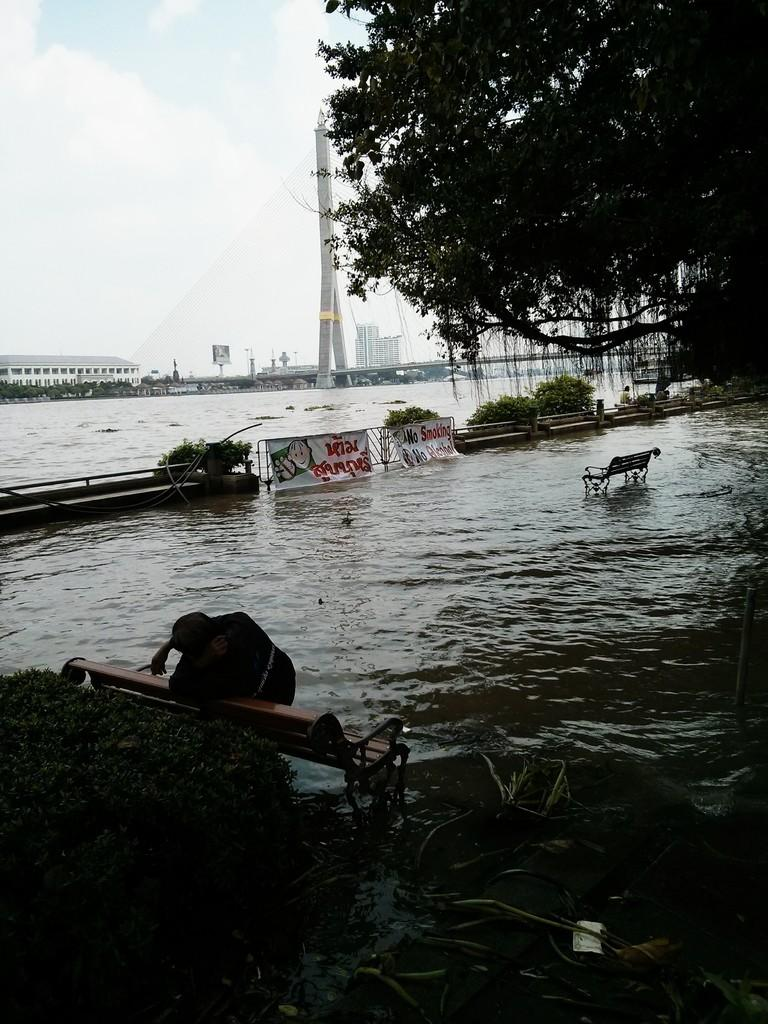What type of seating can be seen in the image? There are benches in the image. What decorative elements are present in the image? There are banners in the image. What type of barrier is visible in the image? There is a fence in the image. What natural element is visible in the image? There is water visible in the image. What type of vegetation is present in the image? There are trees in the image. What type of man-made structures are visible in the image? There are buildings in the image. What is visible in the background of the image? The sky with clouds is visible in the background of the image. Can you tell me how many birds are perched on the banners in the image? There are no birds present in the image; only benches, banners, a fence, water, trees, buildings, and the sky with clouds are visible. What type of badge is being worn by the trees in the image? There are no badges present in the image; only benches, banners, a fence, water, trees, buildings, and the sky with clouds are visible. 